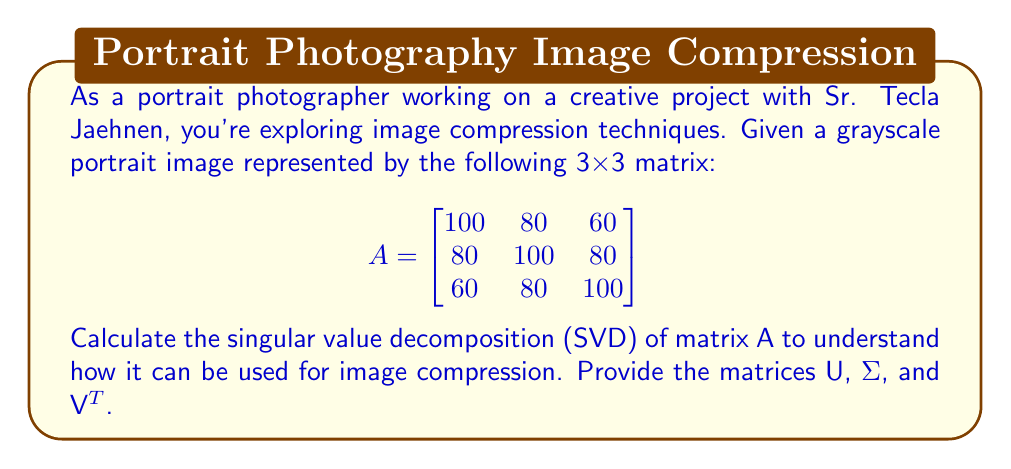Teach me how to tackle this problem. To calculate the singular value decomposition (SVD) of matrix A, we need to find matrices U, Σ, and V^T such that A = UΣV^T.

Step 1: Calculate A^T A and AA^T
$$A^T A = \begin{bmatrix}
20600 & 22400 & 20600 \\
22400 & 24400 & 22400 \\
20600 & 22400 & 20600
\end{bmatrix}$$

$$AA^T = \begin{bmatrix}
20600 & 22400 & 20600 \\
22400 & 24400 & 22400 \\
20600 & 22400 & 20600
\end{bmatrix}$$

Step 2: Find eigenvalues of A^T A (which are the same as AA^T)
Characteristic equation: $(\lambda - 65600)(\lambda - 20)^2 = 0$
Eigenvalues: $\lambda_1 = 65600, \lambda_2 = \lambda_3 = 20$

Step 3: Calculate singular values (square roots of eigenvalues)
$\sigma_1 = \sqrt{65600} = 256$
$\sigma_2 = \sigma_3 = \sqrt{20} \approx 4.47$

Step 4: Find eigenvectors of A^T A to get V
$$v_1 = \frac{1}{\sqrt{3}}\begin{bmatrix} 1 \\ 1 \\ 1 \end{bmatrix},
v_2 = \frac{1}{\sqrt{2}}\begin{bmatrix} 1 \\ 0 \\ -1 \end{bmatrix},
v_3 = \frac{1}{\sqrt{6}}\begin{bmatrix} 1 \\ -2 \\ 1 \end{bmatrix}$$

Step 5: Find eigenvectors of AA^T to get U (same as V in this case)

Step 6: Construct matrices U, Σ, and V^T

$$U = V = \begin{bmatrix}
\frac{1}{\sqrt{3}} & \frac{1}{\sqrt{2}} & \frac{1}{\sqrt{6}} \\
\frac{1}{\sqrt{3}} & 0 & -\frac{2}{\sqrt{6}} \\
\frac{1}{\sqrt{3}} & -\frac{1}{\sqrt{2}} & \frac{1}{\sqrt{6}}
\end{bmatrix}$$

$$\Sigma = \begin{bmatrix}
256 & 0 & 0 \\
0 & 4.47 & 0 \\
0 & 0 & 4.47
\end{bmatrix}$$

$$V^T = \begin{bmatrix}
\frac{1}{\sqrt{3}} & \frac{1}{\sqrt{3}} & \frac{1}{\sqrt{3}} \\
\frac{1}{\sqrt{2}} & 0 & -\frac{1}{\sqrt{2}} \\
\frac{1}{\sqrt{6}} & -\frac{2}{\sqrt{6}} & \frac{1}{\sqrt{6}}
\end{bmatrix}$$
Answer: $U = V = \begin{bmatrix}
\frac{1}{\sqrt{3}} & \frac{1}{\sqrt{2}} & \frac{1}{\sqrt{6}} \\
\frac{1}{\sqrt{3}} & 0 & -\frac{2}{\sqrt{6}} \\
\frac{1}{\sqrt{3}} & -\frac{1}{\sqrt{2}} & \frac{1}{\sqrt{6}}
\end{bmatrix}$, $\Sigma = \begin{bmatrix}
256 & 0 & 0 \\
0 & 4.47 & 0 \\
0 & 0 & 4.47
\end{bmatrix}$, $V^T = U^T$ 